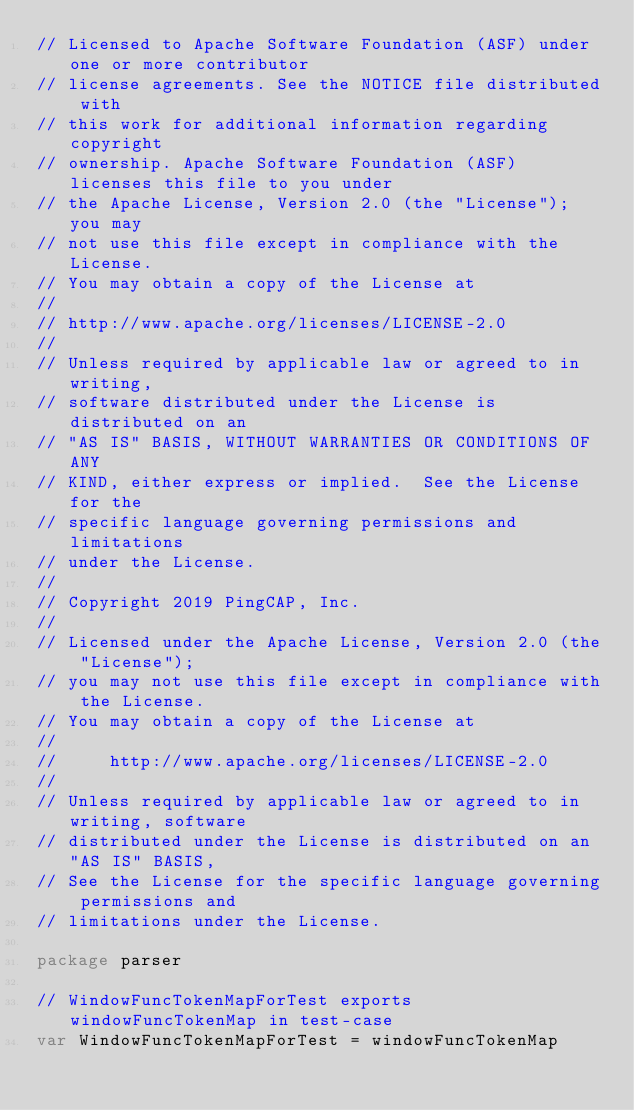Convert code to text. <code><loc_0><loc_0><loc_500><loc_500><_Go_>// Licensed to Apache Software Foundation (ASF) under one or more contributor
// license agreements. See the NOTICE file distributed with
// this work for additional information regarding copyright
// ownership. Apache Software Foundation (ASF) licenses this file to you under
// the Apache License, Version 2.0 (the "License"); you may
// not use this file except in compliance with the License.
// You may obtain a copy of the License at
//
// http://www.apache.org/licenses/LICENSE-2.0
//
// Unless required by applicable law or agreed to in writing,
// software distributed under the License is distributed on an
// "AS IS" BASIS, WITHOUT WARRANTIES OR CONDITIONS OF ANY
// KIND, either express or implied.  See the License for the
// specific language governing permissions and limitations
// under the License.
//
// Copyright 2019 PingCAP, Inc.
//
// Licensed under the Apache License, Version 2.0 (the "License");
// you may not use this file except in compliance with the License.
// You may obtain a copy of the License at
//
//     http://www.apache.org/licenses/LICENSE-2.0
//
// Unless required by applicable law or agreed to in writing, software
// distributed under the License is distributed on an "AS IS" BASIS,
// See the License for the specific language governing permissions and
// limitations under the License.

package parser

// WindowFuncTokenMapForTest exports windowFuncTokenMap in test-case
var WindowFuncTokenMapForTest = windowFuncTokenMap
</code> 